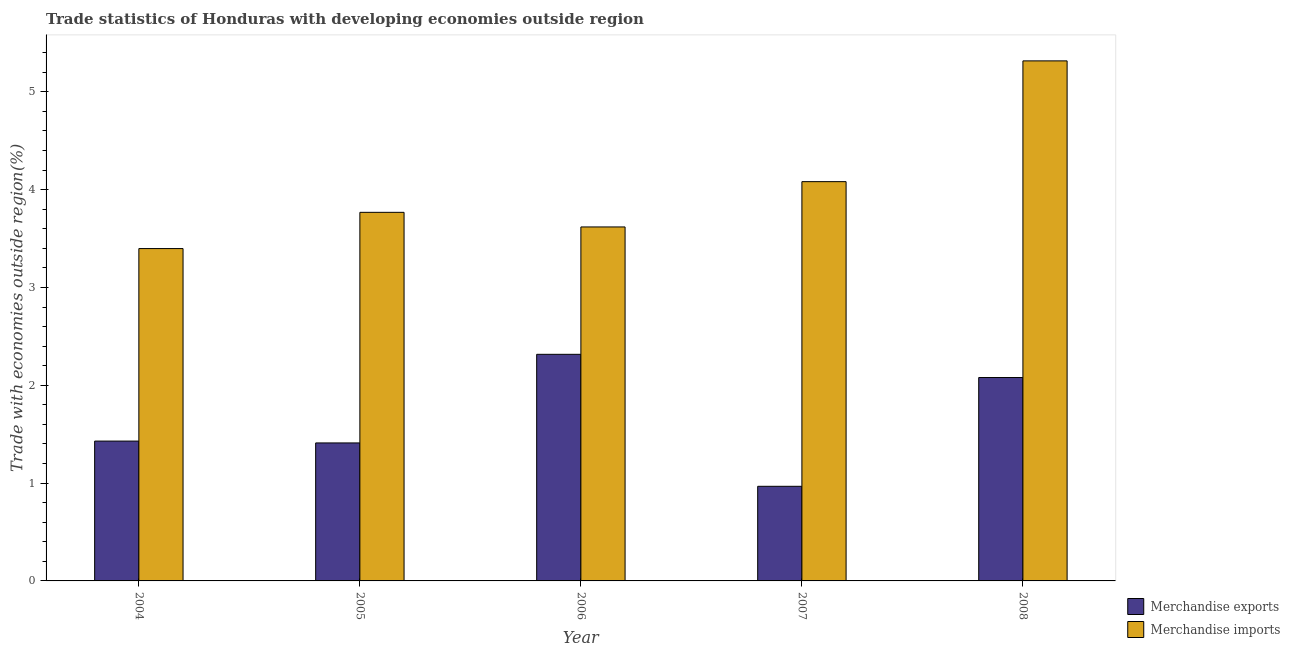How many different coloured bars are there?
Ensure brevity in your answer.  2. How many groups of bars are there?
Offer a very short reply. 5. Are the number of bars on each tick of the X-axis equal?
Provide a succinct answer. Yes. How many bars are there on the 2nd tick from the left?
Give a very brief answer. 2. In how many cases, is the number of bars for a given year not equal to the number of legend labels?
Provide a succinct answer. 0. What is the merchandise exports in 2008?
Provide a short and direct response. 2.08. Across all years, what is the maximum merchandise exports?
Offer a terse response. 2.32. Across all years, what is the minimum merchandise exports?
Your response must be concise. 0.97. In which year was the merchandise exports maximum?
Provide a short and direct response. 2006. In which year was the merchandise exports minimum?
Provide a succinct answer. 2007. What is the total merchandise exports in the graph?
Your answer should be compact. 8.2. What is the difference between the merchandise imports in 2006 and that in 2007?
Your answer should be very brief. -0.46. What is the difference between the merchandise imports in 2008 and the merchandise exports in 2004?
Give a very brief answer. 1.92. What is the average merchandise imports per year?
Your answer should be compact. 4.04. In the year 2007, what is the difference between the merchandise exports and merchandise imports?
Provide a succinct answer. 0. What is the ratio of the merchandise exports in 2004 to that in 2005?
Ensure brevity in your answer.  1.01. What is the difference between the highest and the second highest merchandise imports?
Your answer should be compact. 1.23. What is the difference between the highest and the lowest merchandise imports?
Provide a succinct answer. 1.92. Is the sum of the merchandise imports in 2005 and 2006 greater than the maximum merchandise exports across all years?
Make the answer very short. Yes. What does the 2nd bar from the right in 2005 represents?
Your answer should be very brief. Merchandise exports. Are all the bars in the graph horizontal?
Offer a terse response. No. How many years are there in the graph?
Make the answer very short. 5. Are the values on the major ticks of Y-axis written in scientific E-notation?
Provide a short and direct response. No. Does the graph contain grids?
Keep it short and to the point. No. How many legend labels are there?
Ensure brevity in your answer.  2. How are the legend labels stacked?
Make the answer very short. Vertical. What is the title of the graph?
Ensure brevity in your answer.  Trade statistics of Honduras with developing economies outside region. Does "Largest city" appear as one of the legend labels in the graph?
Give a very brief answer. No. What is the label or title of the X-axis?
Offer a terse response. Year. What is the label or title of the Y-axis?
Provide a succinct answer. Trade with economies outside region(%). What is the Trade with economies outside region(%) in Merchandise exports in 2004?
Provide a succinct answer. 1.43. What is the Trade with economies outside region(%) of Merchandise imports in 2004?
Your response must be concise. 3.4. What is the Trade with economies outside region(%) in Merchandise exports in 2005?
Give a very brief answer. 1.41. What is the Trade with economies outside region(%) in Merchandise imports in 2005?
Provide a succinct answer. 3.77. What is the Trade with economies outside region(%) of Merchandise exports in 2006?
Offer a very short reply. 2.32. What is the Trade with economies outside region(%) of Merchandise imports in 2006?
Your answer should be very brief. 3.62. What is the Trade with economies outside region(%) in Merchandise exports in 2007?
Keep it short and to the point. 0.97. What is the Trade with economies outside region(%) in Merchandise imports in 2007?
Keep it short and to the point. 4.08. What is the Trade with economies outside region(%) in Merchandise exports in 2008?
Keep it short and to the point. 2.08. What is the Trade with economies outside region(%) in Merchandise imports in 2008?
Your answer should be compact. 5.32. Across all years, what is the maximum Trade with economies outside region(%) in Merchandise exports?
Provide a short and direct response. 2.32. Across all years, what is the maximum Trade with economies outside region(%) of Merchandise imports?
Give a very brief answer. 5.32. Across all years, what is the minimum Trade with economies outside region(%) of Merchandise exports?
Offer a terse response. 0.97. Across all years, what is the minimum Trade with economies outside region(%) in Merchandise imports?
Keep it short and to the point. 3.4. What is the total Trade with economies outside region(%) of Merchandise exports in the graph?
Your answer should be very brief. 8.2. What is the total Trade with economies outside region(%) of Merchandise imports in the graph?
Provide a succinct answer. 20.18. What is the difference between the Trade with economies outside region(%) in Merchandise exports in 2004 and that in 2005?
Your answer should be very brief. 0.02. What is the difference between the Trade with economies outside region(%) of Merchandise imports in 2004 and that in 2005?
Give a very brief answer. -0.37. What is the difference between the Trade with economies outside region(%) in Merchandise exports in 2004 and that in 2006?
Provide a short and direct response. -0.89. What is the difference between the Trade with economies outside region(%) of Merchandise imports in 2004 and that in 2006?
Your response must be concise. -0.22. What is the difference between the Trade with economies outside region(%) of Merchandise exports in 2004 and that in 2007?
Your response must be concise. 0.46. What is the difference between the Trade with economies outside region(%) in Merchandise imports in 2004 and that in 2007?
Make the answer very short. -0.68. What is the difference between the Trade with economies outside region(%) of Merchandise exports in 2004 and that in 2008?
Keep it short and to the point. -0.65. What is the difference between the Trade with economies outside region(%) in Merchandise imports in 2004 and that in 2008?
Provide a short and direct response. -1.92. What is the difference between the Trade with economies outside region(%) in Merchandise exports in 2005 and that in 2006?
Give a very brief answer. -0.91. What is the difference between the Trade with economies outside region(%) in Merchandise imports in 2005 and that in 2006?
Keep it short and to the point. 0.15. What is the difference between the Trade with economies outside region(%) of Merchandise exports in 2005 and that in 2007?
Ensure brevity in your answer.  0.44. What is the difference between the Trade with economies outside region(%) of Merchandise imports in 2005 and that in 2007?
Your response must be concise. -0.31. What is the difference between the Trade with economies outside region(%) in Merchandise exports in 2005 and that in 2008?
Offer a very short reply. -0.67. What is the difference between the Trade with economies outside region(%) in Merchandise imports in 2005 and that in 2008?
Your answer should be compact. -1.55. What is the difference between the Trade with economies outside region(%) of Merchandise exports in 2006 and that in 2007?
Offer a terse response. 1.35. What is the difference between the Trade with economies outside region(%) in Merchandise imports in 2006 and that in 2007?
Provide a short and direct response. -0.46. What is the difference between the Trade with economies outside region(%) in Merchandise exports in 2006 and that in 2008?
Your answer should be compact. 0.24. What is the difference between the Trade with economies outside region(%) in Merchandise imports in 2006 and that in 2008?
Provide a short and direct response. -1.7. What is the difference between the Trade with economies outside region(%) in Merchandise exports in 2007 and that in 2008?
Offer a very short reply. -1.11. What is the difference between the Trade with economies outside region(%) in Merchandise imports in 2007 and that in 2008?
Keep it short and to the point. -1.23. What is the difference between the Trade with economies outside region(%) of Merchandise exports in 2004 and the Trade with economies outside region(%) of Merchandise imports in 2005?
Make the answer very short. -2.34. What is the difference between the Trade with economies outside region(%) of Merchandise exports in 2004 and the Trade with economies outside region(%) of Merchandise imports in 2006?
Your response must be concise. -2.19. What is the difference between the Trade with economies outside region(%) of Merchandise exports in 2004 and the Trade with economies outside region(%) of Merchandise imports in 2007?
Offer a very short reply. -2.65. What is the difference between the Trade with economies outside region(%) in Merchandise exports in 2004 and the Trade with economies outside region(%) in Merchandise imports in 2008?
Offer a very short reply. -3.89. What is the difference between the Trade with economies outside region(%) in Merchandise exports in 2005 and the Trade with economies outside region(%) in Merchandise imports in 2006?
Your answer should be very brief. -2.21. What is the difference between the Trade with economies outside region(%) in Merchandise exports in 2005 and the Trade with economies outside region(%) in Merchandise imports in 2007?
Offer a very short reply. -2.67. What is the difference between the Trade with economies outside region(%) in Merchandise exports in 2005 and the Trade with economies outside region(%) in Merchandise imports in 2008?
Offer a terse response. -3.91. What is the difference between the Trade with economies outside region(%) in Merchandise exports in 2006 and the Trade with economies outside region(%) in Merchandise imports in 2007?
Offer a very short reply. -1.76. What is the difference between the Trade with economies outside region(%) of Merchandise exports in 2006 and the Trade with economies outside region(%) of Merchandise imports in 2008?
Provide a succinct answer. -3. What is the difference between the Trade with economies outside region(%) of Merchandise exports in 2007 and the Trade with economies outside region(%) of Merchandise imports in 2008?
Ensure brevity in your answer.  -4.35. What is the average Trade with economies outside region(%) of Merchandise exports per year?
Provide a succinct answer. 1.64. What is the average Trade with economies outside region(%) in Merchandise imports per year?
Your answer should be compact. 4.04. In the year 2004, what is the difference between the Trade with economies outside region(%) in Merchandise exports and Trade with economies outside region(%) in Merchandise imports?
Keep it short and to the point. -1.97. In the year 2005, what is the difference between the Trade with economies outside region(%) in Merchandise exports and Trade with economies outside region(%) in Merchandise imports?
Your answer should be compact. -2.36. In the year 2006, what is the difference between the Trade with economies outside region(%) of Merchandise exports and Trade with economies outside region(%) of Merchandise imports?
Give a very brief answer. -1.3. In the year 2007, what is the difference between the Trade with economies outside region(%) of Merchandise exports and Trade with economies outside region(%) of Merchandise imports?
Provide a short and direct response. -3.11. In the year 2008, what is the difference between the Trade with economies outside region(%) in Merchandise exports and Trade with economies outside region(%) in Merchandise imports?
Keep it short and to the point. -3.24. What is the ratio of the Trade with economies outside region(%) in Merchandise exports in 2004 to that in 2005?
Provide a short and direct response. 1.01. What is the ratio of the Trade with economies outside region(%) in Merchandise imports in 2004 to that in 2005?
Your answer should be very brief. 0.9. What is the ratio of the Trade with economies outside region(%) of Merchandise exports in 2004 to that in 2006?
Your answer should be compact. 0.62. What is the ratio of the Trade with economies outside region(%) of Merchandise imports in 2004 to that in 2006?
Keep it short and to the point. 0.94. What is the ratio of the Trade with economies outside region(%) of Merchandise exports in 2004 to that in 2007?
Your response must be concise. 1.48. What is the ratio of the Trade with economies outside region(%) in Merchandise imports in 2004 to that in 2007?
Give a very brief answer. 0.83. What is the ratio of the Trade with economies outside region(%) in Merchandise exports in 2004 to that in 2008?
Give a very brief answer. 0.69. What is the ratio of the Trade with economies outside region(%) in Merchandise imports in 2004 to that in 2008?
Make the answer very short. 0.64. What is the ratio of the Trade with economies outside region(%) of Merchandise exports in 2005 to that in 2006?
Ensure brevity in your answer.  0.61. What is the ratio of the Trade with economies outside region(%) of Merchandise imports in 2005 to that in 2006?
Your answer should be compact. 1.04. What is the ratio of the Trade with economies outside region(%) in Merchandise exports in 2005 to that in 2007?
Offer a very short reply. 1.46. What is the ratio of the Trade with economies outside region(%) of Merchandise imports in 2005 to that in 2007?
Provide a succinct answer. 0.92. What is the ratio of the Trade with economies outside region(%) of Merchandise exports in 2005 to that in 2008?
Ensure brevity in your answer.  0.68. What is the ratio of the Trade with economies outside region(%) in Merchandise imports in 2005 to that in 2008?
Offer a terse response. 0.71. What is the ratio of the Trade with economies outside region(%) in Merchandise exports in 2006 to that in 2007?
Make the answer very short. 2.39. What is the ratio of the Trade with economies outside region(%) in Merchandise imports in 2006 to that in 2007?
Give a very brief answer. 0.89. What is the ratio of the Trade with economies outside region(%) of Merchandise exports in 2006 to that in 2008?
Offer a very short reply. 1.11. What is the ratio of the Trade with economies outside region(%) in Merchandise imports in 2006 to that in 2008?
Your response must be concise. 0.68. What is the ratio of the Trade with economies outside region(%) in Merchandise exports in 2007 to that in 2008?
Your answer should be compact. 0.47. What is the ratio of the Trade with economies outside region(%) in Merchandise imports in 2007 to that in 2008?
Keep it short and to the point. 0.77. What is the difference between the highest and the second highest Trade with economies outside region(%) of Merchandise exports?
Your answer should be very brief. 0.24. What is the difference between the highest and the second highest Trade with economies outside region(%) in Merchandise imports?
Keep it short and to the point. 1.23. What is the difference between the highest and the lowest Trade with economies outside region(%) in Merchandise exports?
Make the answer very short. 1.35. What is the difference between the highest and the lowest Trade with economies outside region(%) of Merchandise imports?
Give a very brief answer. 1.92. 